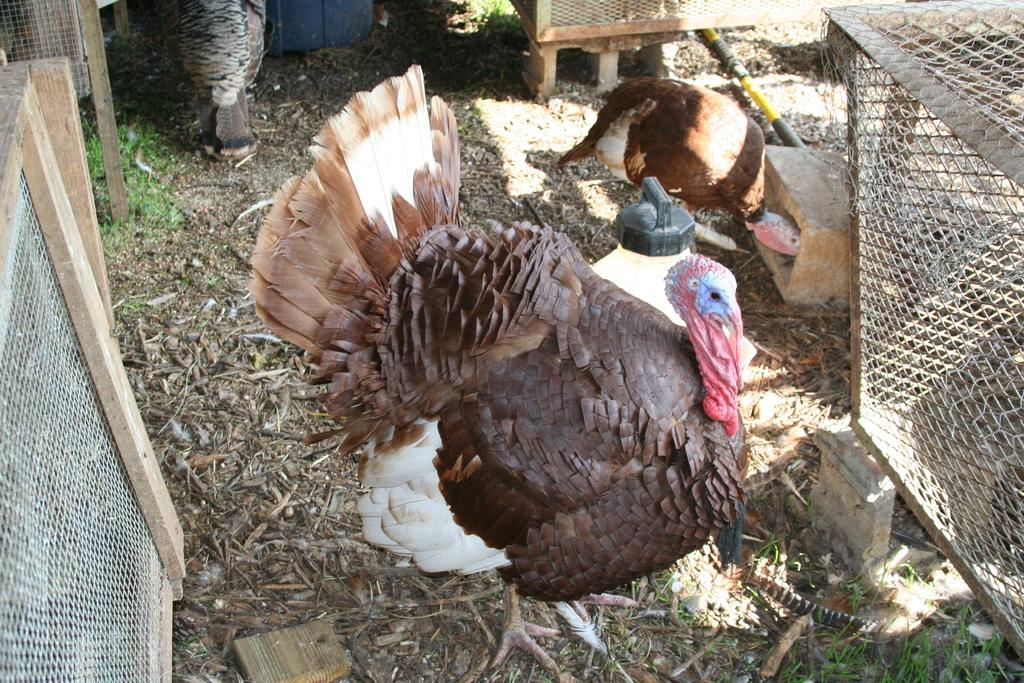What type of animals can be seen in the image? There are hens in the image. What structures are visible in the image? There are meshes in the image. What type of vegetation is present in the image? There is grass in the image. What man-made objects can be seen in the image? There is a bottle and a pipe in the image. What natural elements are present in the image? Dried leaves and sticks are present in the image. What type of hair can be seen on the hens in the image? There is no hair present on the hens in the image; they have feathers. 